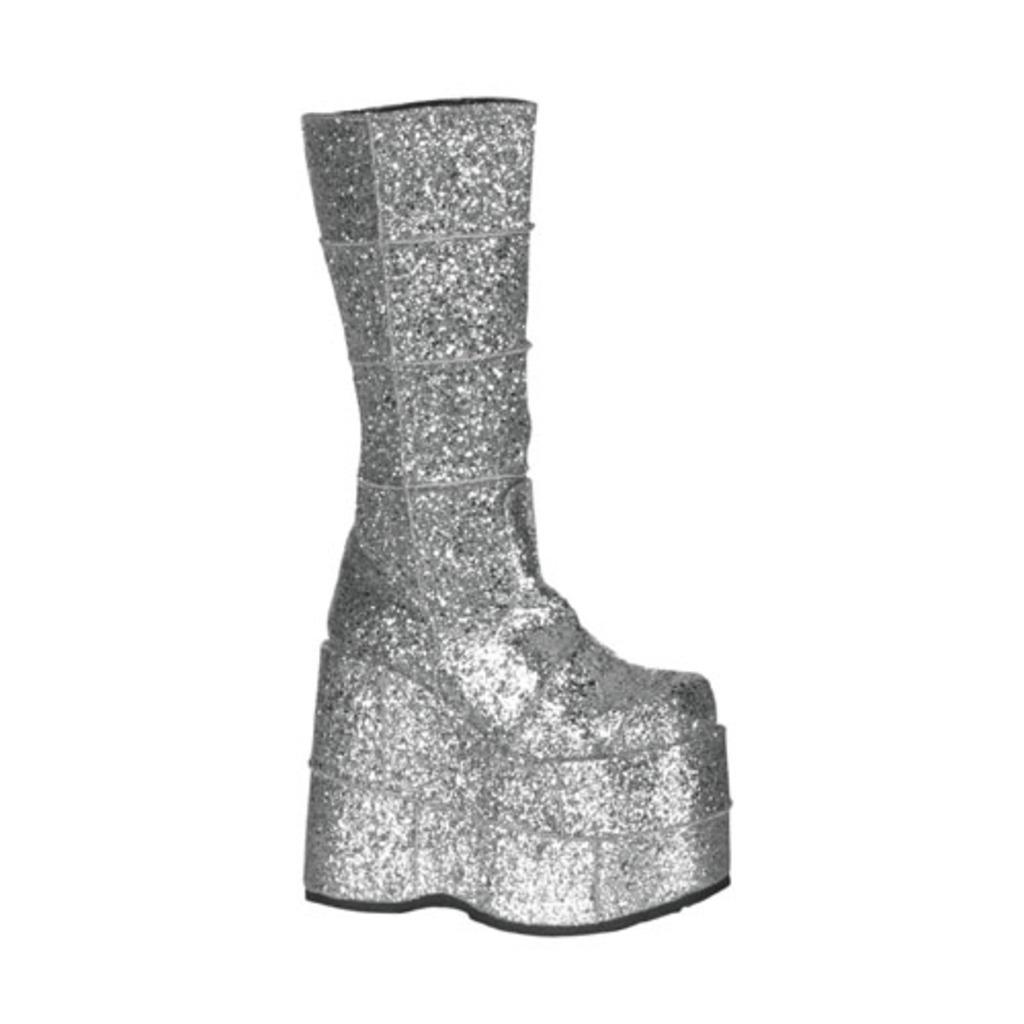What color is the boot in the image? The boot in the image is silver in color. What advice does the father give about the development of the parcel in the image? There is no father or parcel present in the image, as it only features a silver color boot. 